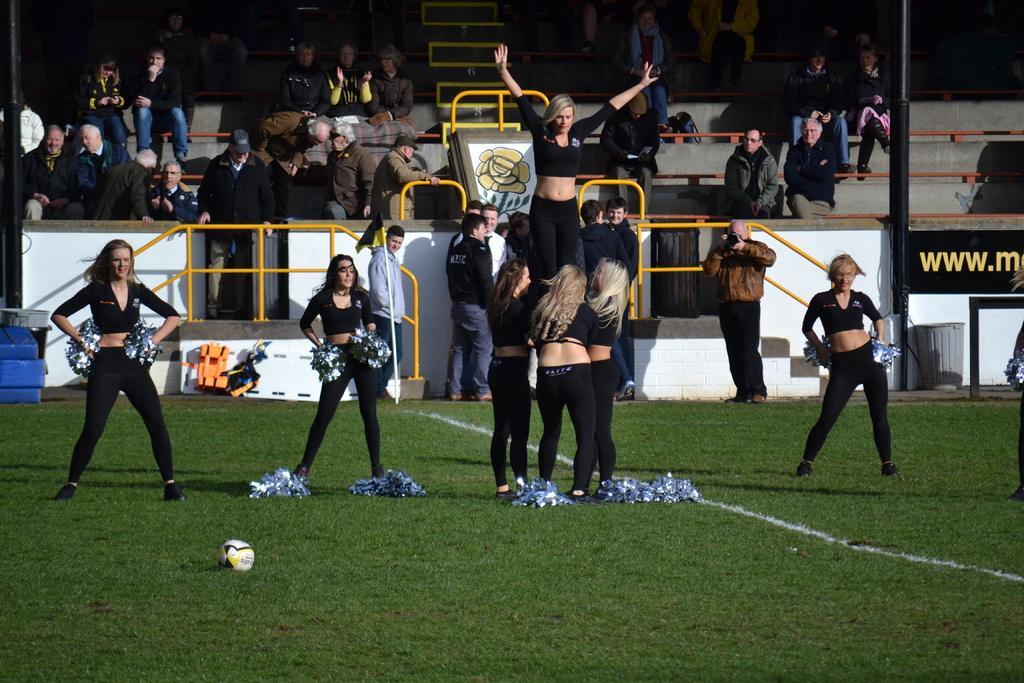Could you give a brief overview of what you see in this image? In this image, there are cheer girls on the ground. There are some persons at the top of the image wearing clothes and sitting on benches. There is a ball in the bottom left of the image. There is a pole on the right side of the image. 